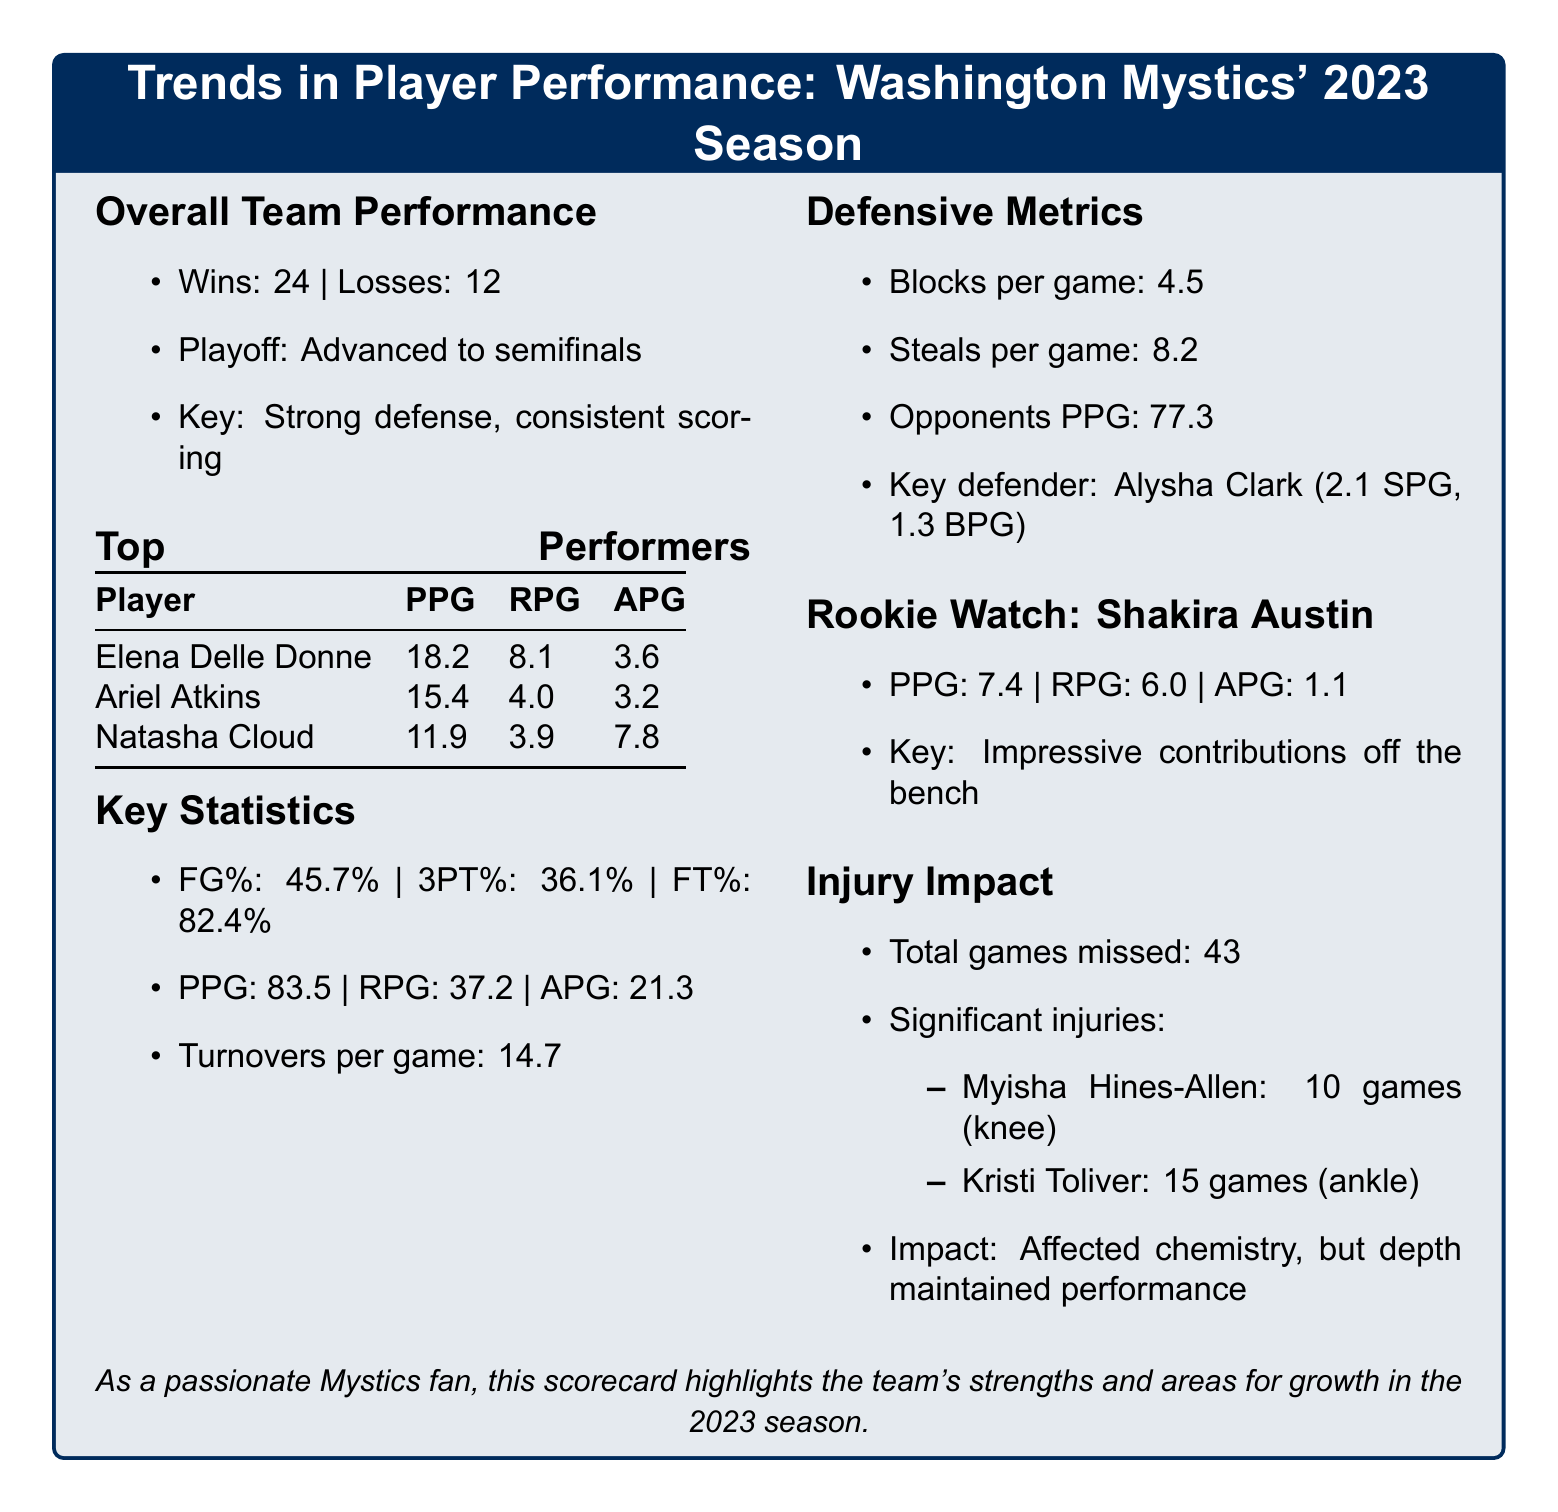Who was the key defender for the Mystics in 2023? The document identifies Alysha Clark as the key defender, highlighting her statistics.
Answer: Alysha Clark What is Elena Delle Donne's points per game (PPG)? The PPG for Elena Delle Donne is provided in the top performers table.
Answer: 18.2 How many total games did the team miss due to injuries? The total games missed due to injuries is listed in the injury impact section.
Answer: 43 What is the team’s three-point shooting percentage (3PT%)? The three-point shooting percentage is a key statistic included in the overall performance data.
Answer: 36.1% Which player had the highest assists per game (APG)? The assists per game for each top performer is given, allowing for comparison.
Answer: Natasha Cloud How many games did Kristi Toliver miss? The document specifies the number of games Kristi Toliver missed due to injury in the injury impact section.
Answer: 15 What is the average rebounds per game (RPG) for Ariel Atkins? The RPG for Ariel Atkins is provided in the player performance table, which includes key statistics.
Answer: 4.0 What playoffs stage did the Mystics reach in 2023? The advancement to semifinals is stated under overall team performance.
Answer: Semifinals 